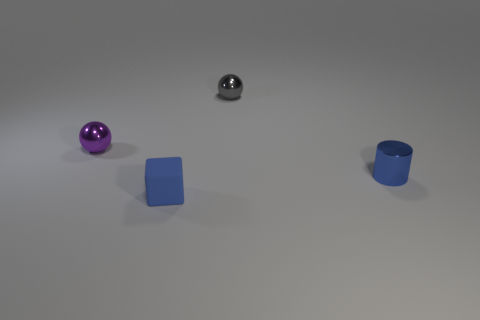Add 1 large cyan cylinders. How many objects exist? 5 Subtract 1 blocks. How many blocks are left? 0 Subtract all tiny metallic objects. Subtract all brown shiny blocks. How many objects are left? 1 Add 1 small blue rubber things. How many small blue rubber things are left? 2 Add 2 small blue shiny cylinders. How many small blue shiny cylinders exist? 3 Subtract 0 purple blocks. How many objects are left? 4 Subtract all brown spheres. Subtract all blue cylinders. How many spheres are left? 2 